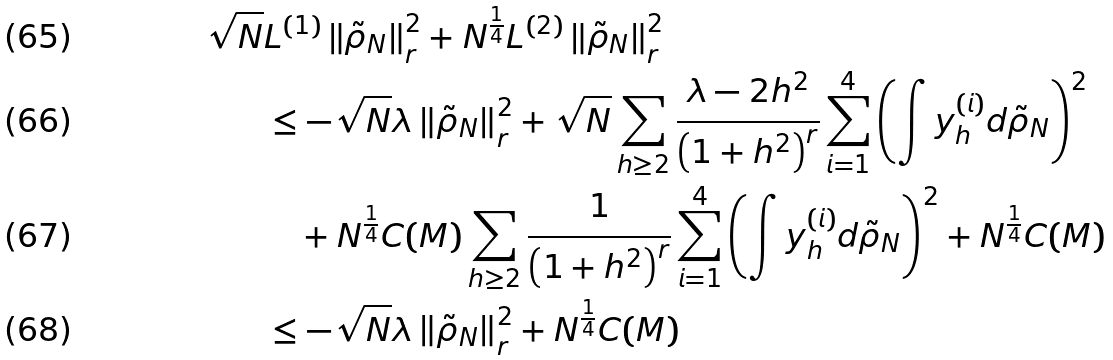Convert formula to latex. <formula><loc_0><loc_0><loc_500><loc_500>\sqrt { N } & L ^ { ( 1 ) } \left \| \tilde { \rho } _ { N } \right \| ^ { 2 } _ { r } + N ^ { \frac { 1 } { 4 } } L ^ { ( 2 ) } \left \| \tilde { \rho } _ { N } \right \| ^ { 2 } _ { r } \\ & \leq - \sqrt { N } \lambda \left \| \tilde { \rho } _ { N } \right \| ^ { 2 } _ { r } + \sqrt { N } \sum _ { h \geq 2 } \frac { \lambda - 2 h ^ { 2 } } { \left ( 1 + h ^ { 2 } \right ) ^ { r } } \sum _ { i = 1 } ^ { 4 } \left ( \int y _ { h } ^ { ( i ) } d \tilde { \rho } _ { N } \right ) ^ { 2 } \\ & \quad + N ^ { \frac { 1 } { 4 } } C ( M ) \sum _ { h \geq 2 } \frac { 1 } { \left ( 1 + h ^ { 2 } \right ) ^ { r } } \sum _ { i = 1 } ^ { 4 } \left ( \int y _ { h } ^ { ( i ) } d \tilde { \rho } _ { N } \right ) ^ { 2 } + N ^ { \frac { 1 } { 4 } } C ( M ) \\ & \leq - \sqrt { N } \lambda \left \| \tilde { \rho } _ { N } \right \| ^ { 2 } _ { r } + N ^ { \frac { 1 } { 4 } } C ( M )</formula> 